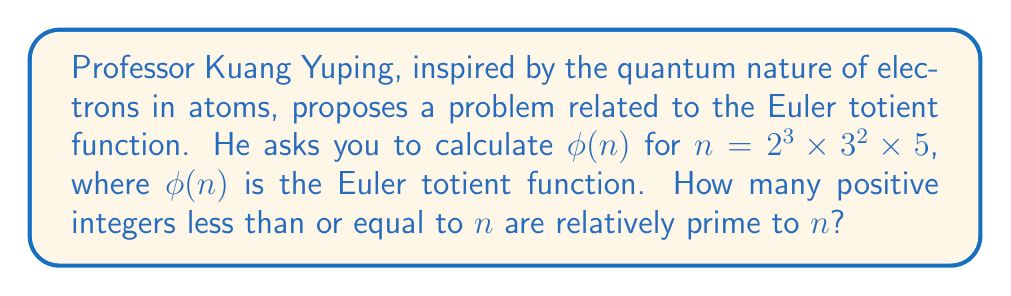Teach me how to tackle this problem. To solve this problem, we'll follow these steps:

1) First, recall the properties of the Euler totient function:
   - For a prime number $p$, $\phi(p) = p - 1$
   - For prime powers $p^k$, $\phi(p^k) = p^k - p^{k-1} = p^k(1 - \frac{1}{p})$
   - For relatively prime numbers $a$ and $b$, $\phi(ab) = \phi(a) \times \phi(b)$

2) Given $n = 2^3 \times 3^2 \times 5$, we need to calculate:
   $\phi(n) = \phi(2^3) \times \phi(3^2) \times \phi(5)$

3) Let's calculate each part:
   - $\phi(2^3) = 2^3 - 2^2 = 8 - 4 = 4$
   - $\phi(3^2) = 3^2 - 3 = 9 - 3 = 6$
   - $\phi(5) = 5 - 1 = 4$

4) Now, we multiply these results:
   $\phi(n) = 4 \times 6 \times 4 = 96$

This result tells us that there are 96 positive integers less than or equal to $n$ that are relatively prime to $n$.

The physical interpretation, relating to Professor Kuang's quantum mechanics background, is that this could represent the number of possible unique quantum states in a simplified model of an atom with energy levels corresponding to the prime factors of $n$.
Answer: $\phi(2^3 \times 3^2 \times 5) = 96$ 